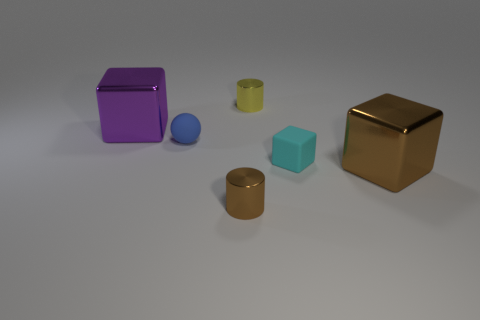Is the number of tiny cylinders in front of the small blue thing the same as the number of blocks?
Give a very brief answer. No. What is the size of the cube that is behind the big brown cube and in front of the large purple metallic object?
Give a very brief answer. Small. There is a tiny thing in front of the large metal object that is in front of the tiny block; what color is it?
Make the answer very short. Brown. What number of purple objects are small objects or large shiny objects?
Provide a short and direct response. 1. The metallic thing that is both left of the tiny yellow object and in front of the purple thing is what color?
Give a very brief answer. Brown. How many large objects are yellow balls or yellow shiny cylinders?
Your answer should be compact. 0. The brown object that is the same shape as the yellow metal object is what size?
Your answer should be very brief. Small. There is a tiny yellow thing; what shape is it?
Keep it short and to the point. Cylinder. Are the small ball and the tiny object that is behind the tiny matte ball made of the same material?
Provide a succinct answer. No. How many metal things are large red objects or tiny blocks?
Offer a terse response. 0. 